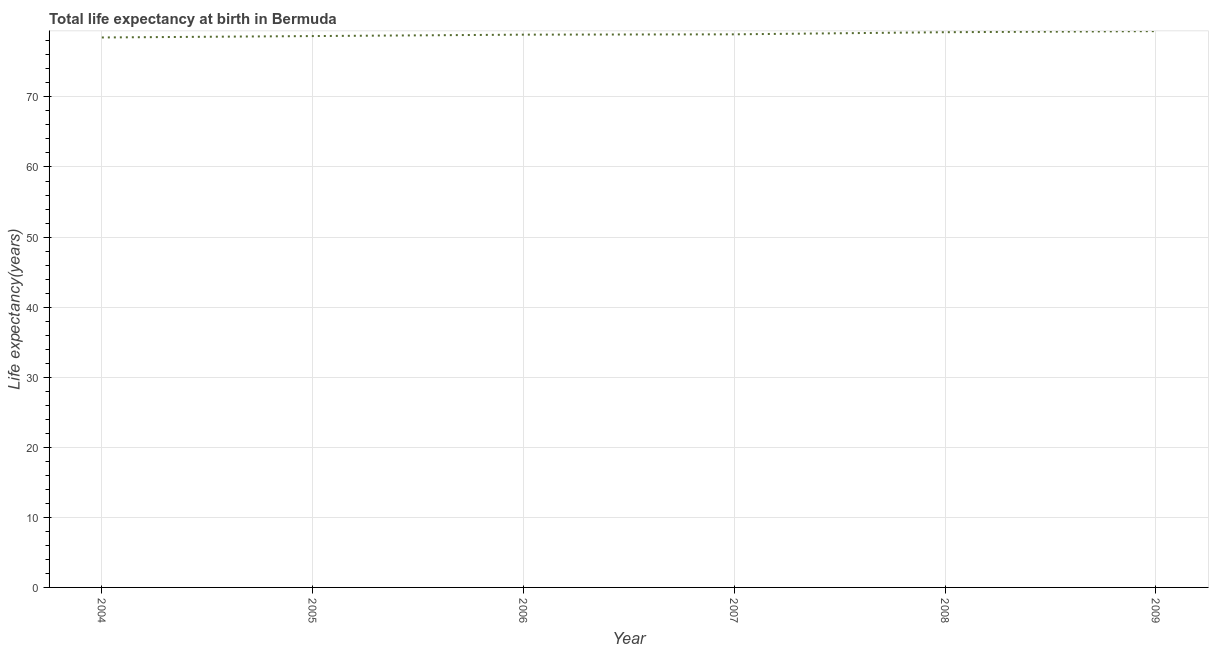What is the life expectancy at birth in 2006?
Offer a very short reply. 78.89. Across all years, what is the maximum life expectancy at birth?
Your answer should be very brief. 79.39. Across all years, what is the minimum life expectancy at birth?
Provide a succinct answer. 78.49. In which year was the life expectancy at birth maximum?
Give a very brief answer. 2009. What is the sum of the life expectancy at birth?
Your answer should be very brief. 473.62. What is the difference between the life expectancy at birth in 2004 and 2005?
Keep it short and to the point. -0.2. What is the average life expectancy at birth per year?
Offer a terse response. 78.94. What is the median life expectancy at birth?
Offer a terse response. 78.91. In how many years, is the life expectancy at birth greater than 72 years?
Keep it short and to the point. 6. Do a majority of the years between 2006 and 2008 (inclusive) have life expectancy at birth greater than 14 years?
Make the answer very short. Yes. What is the ratio of the life expectancy at birth in 2007 to that in 2009?
Make the answer very short. 0.99. Is the life expectancy at birth in 2004 less than that in 2008?
Provide a short and direct response. Yes. What is the difference between the highest and the second highest life expectancy at birth?
Keep it short and to the point. 0.15. Is the sum of the life expectancy at birth in 2005 and 2006 greater than the maximum life expectancy at birth across all years?
Your answer should be very brief. Yes. What is the difference between the highest and the lowest life expectancy at birth?
Give a very brief answer. 0.9. How many years are there in the graph?
Your response must be concise. 6. Are the values on the major ticks of Y-axis written in scientific E-notation?
Your answer should be compact. No. Does the graph contain any zero values?
Provide a short and direct response. No. Does the graph contain grids?
Give a very brief answer. Yes. What is the title of the graph?
Give a very brief answer. Total life expectancy at birth in Bermuda. What is the label or title of the Y-axis?
Keep it short and to the point. Life expectancy(years). What is the Life expectancy(years) in 2004?
Provide a short and direct response. 78.49. What is the Life expectancy(years) in 2005?
Keep it short and to the point. 78.69. What is the Life expectancy(years) of 2006?
Your answer should be very brief. 78.89. What is the Life expectancy(years) in 2007?
Keep it short and to the point. 78.93. What is the Life expectancy(years) of 2008?
Provide a short and direct response. 79.24. What is the Life expectancy(years) of 2009?
Your response must be concise. 79.39. What is the difference between the Life expectancy(years) in 2004 and 2005?
Ensure brevity in your answer.  -0.2. What is the difference between the Life expectancy(years) in 2004 and 2006?
Offer a very short reply. -0.4. What is the difference between the Life expectancy(years) in 2004 and 2007?
Your answer should be very brief. -0.45. What is the difference between the Life expectancy(years) in 2004 and 2008?
Provide a short and direct response. -0.75. What is the difference between the Life expectancy(years) in 2004 and 2009?
Your answer should be compact. -0.9. What is the difference between the Life expectancy(years) in 2005 and 2006?
Provide a succinct answer. -0.2. What is the difference between the Life expectancy(years) in 2005 and 2007?
Make the answer very short. -0.25. What is the difference between the Life expectancy(years) in 2005 and 2008?
Ensure brevity in your answer.  -0.55. What is the difference between the Life expectancy(years) in 2005 and 2009?
Your response must be concise. -0.7. What is the difference between the Life expectancy(years) in 2006 and 2007?
Keep it short and to the point. -0.05. What is the difference between the Life expectancy(years) in 2006 and 2008?
Ensure brevity in your answer.  -0.35. What is the difference between the Life expectancy(years) in 2006 and 2009?
Your response must be concise. -0.5. What is the difference between the Life expectancy(years) in 2007 and 2008?
Provide a succinct answer. -0.3. What is the difference between the Life expectancy(years) in 2007 and 2009?
Give a very brief answer. -0.45. What is the difference between the Life expectancy(years) in 2008 and 2009?
Give a very brief answer. -0.15. What is the ratio of the Life expectancy(years) in 2004 to that in 2005?
Provide a succinct answer. 1. What is the ratio of the Life expectancy(years) in 2004 to that in 2006?
Your response must be concise. 0.99. What is the ratio of the Life expectancy(years) in 2004 to that in 2007?
Your answer should be compact. 0.99. What is the ratio of the Life expectancy(years) in 2004 to that in 2009?
Ensure brevity in your answer.  0.99. What is the ratio of the Life expectancy(years) in 2005 to that in 2008?
Provide a succinct answer. 0.99. What is the ratio of the Life expectancy(years) in 2006 to that in 2008?
Ensure brevity in your answer.  1. What is the ratio of the Life expectancy(years) in 2006 to that in 2009?
Provide a short and direct response. 0.99. What is the ratio of the Life expectancy(years) in 2007 to that in 2008?
Make the answer very short. 1. 